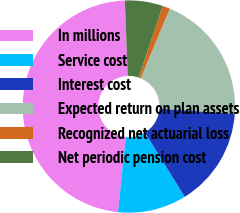<chart> <loc_0><loc_0><loc_500><loc_500><pie_chart><fcel>In millions<fcel>Service cost<fcel>Interest cost<fcel>Expected return on plan assets<fcel>Recognized net actuarial loss<fcel>Net periodic pension cost<nl><fcel>47.77%<fcel>10.45%<fcel>15.11%<fcel>19.78%<fcel>1.12%<fcel>5.78%<nl></chart> 